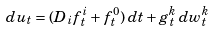Convert formula to latex. <formula><loc_0><loc_0><loc_500><loc_500>d u _ { t } = ( D _ { i } f ^ { i } _ { t } + f ^ { 0 } _ { t } ) \, d t + g ^ { k } _ { t } \, d w ^ { k } _ { t }</formula> 